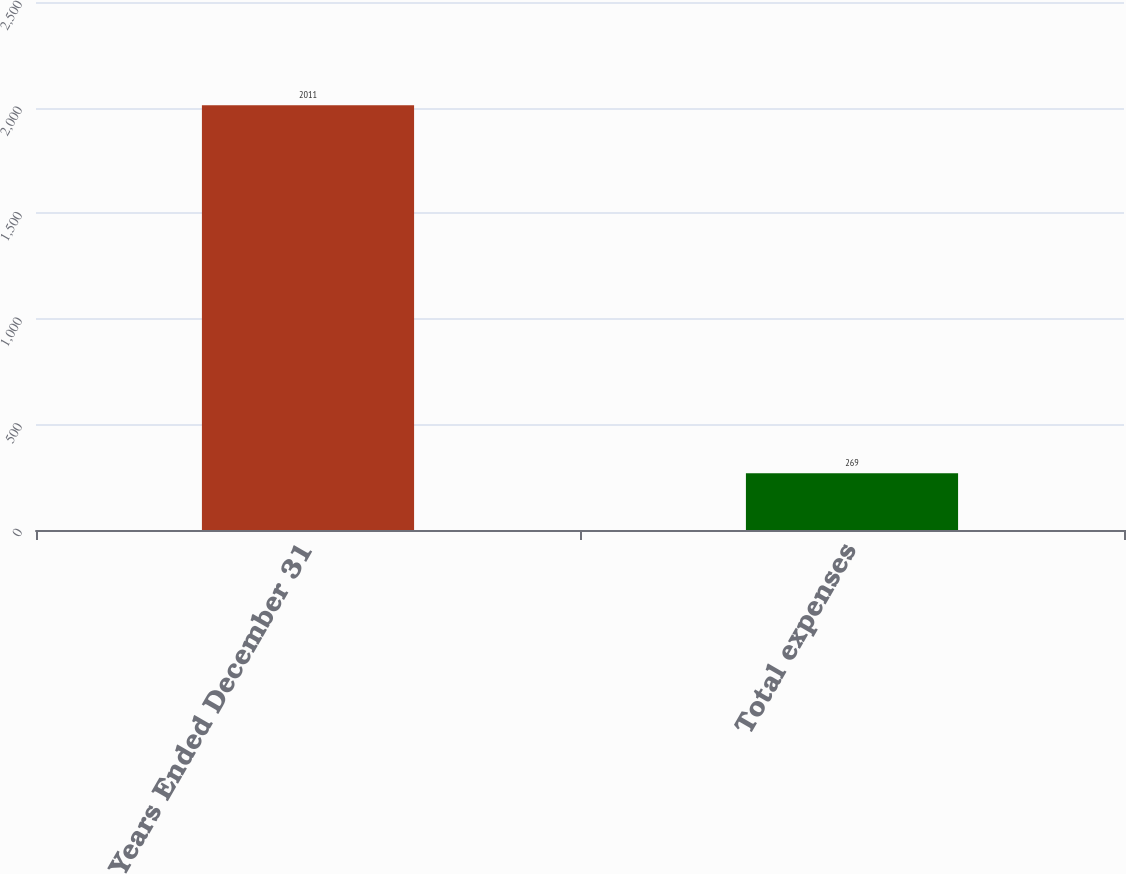Convert chart to OTSL. <chart><loc_0><loc_0><loc_500><loc_500><bar_chart><fcel>Years Ended December 31<fcel>Total expenses<nl><fcel>2011<fcel>269<nl></chart> 